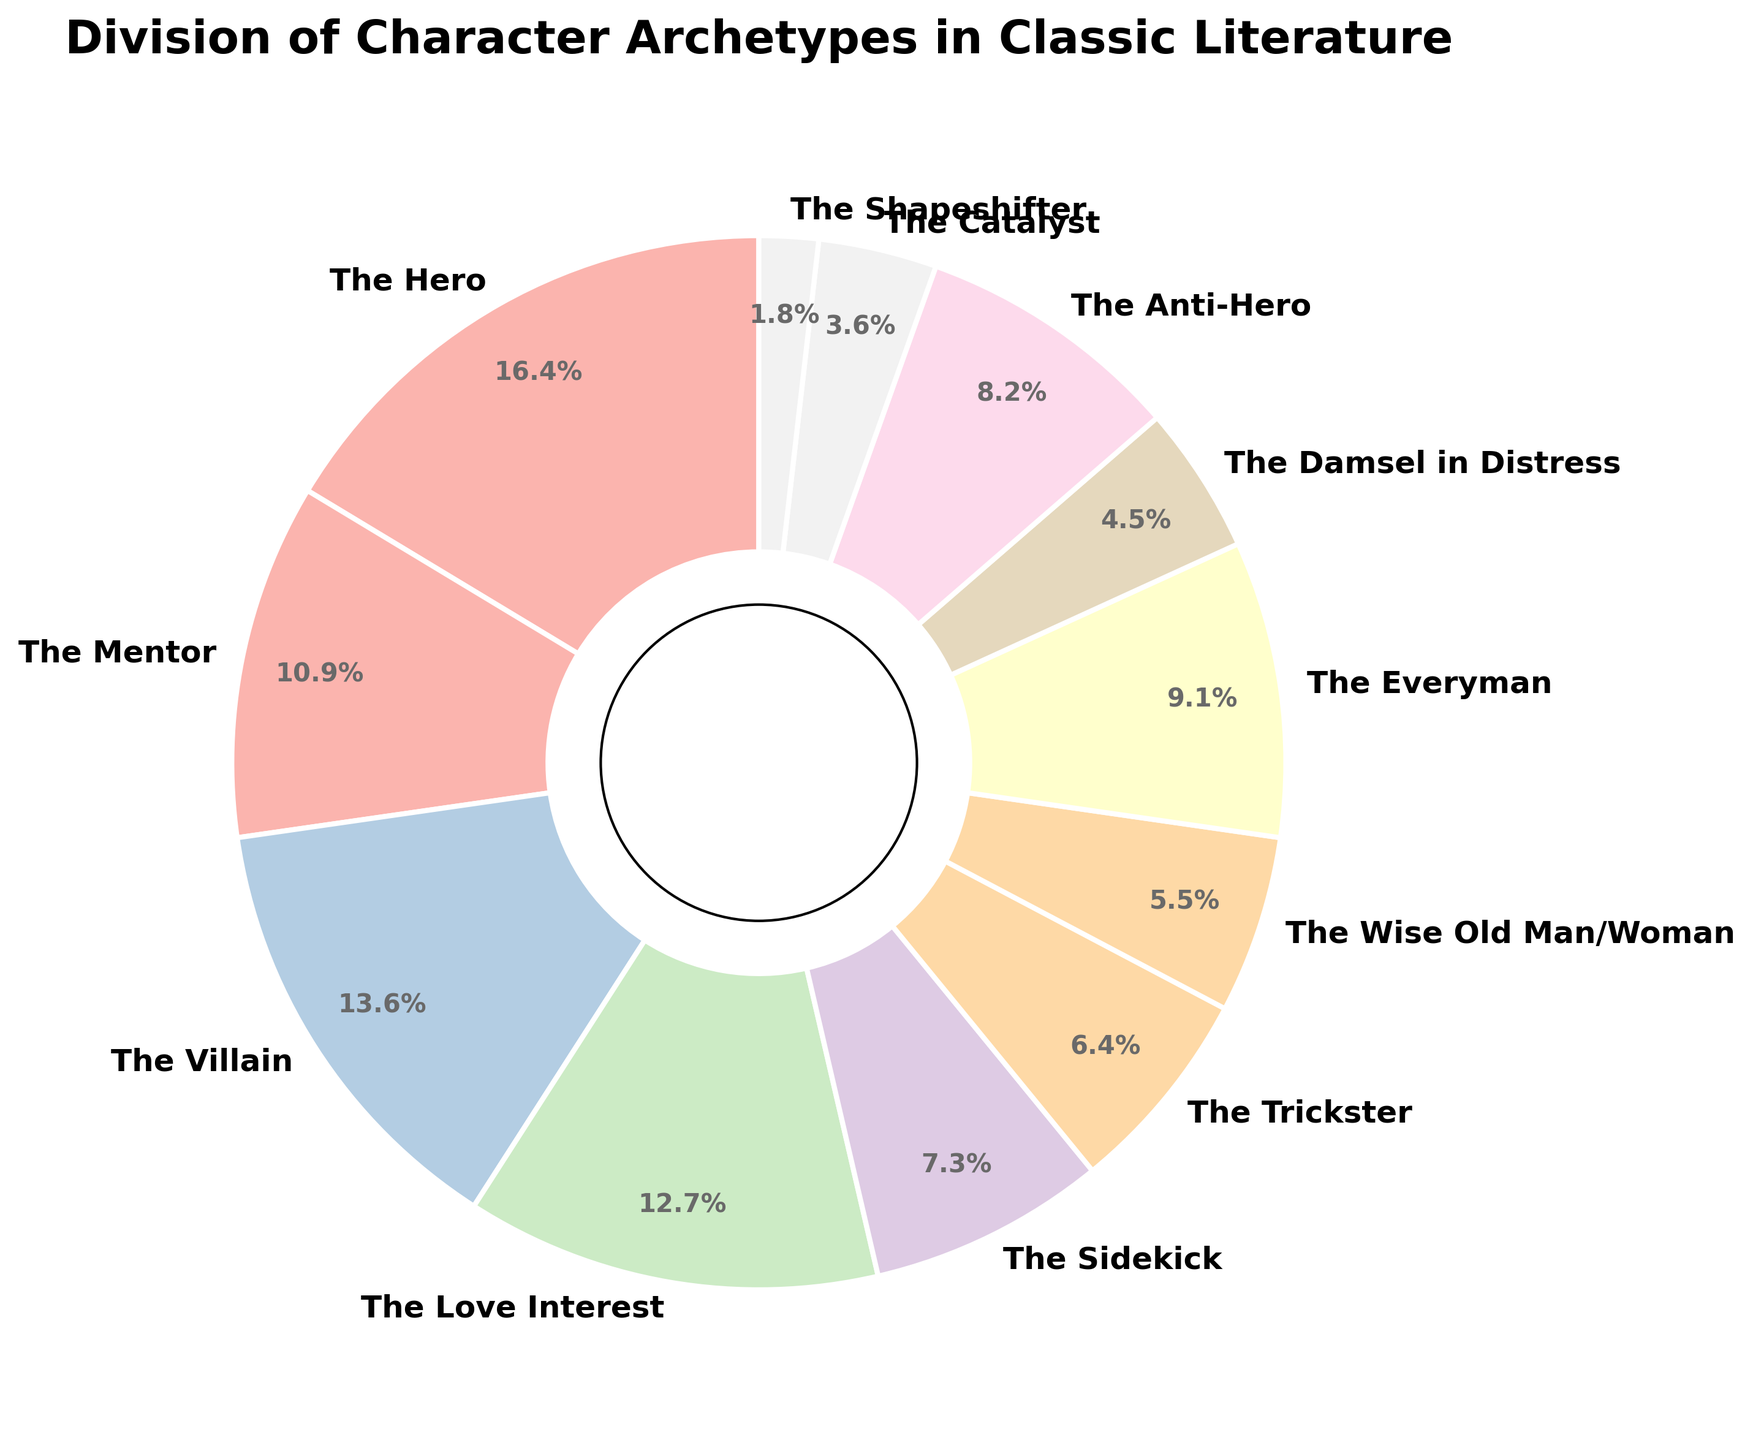Which character archetype has the highest percentage? By looking at the pie chart, we observe that "The Hero" has the largest section. Hence, "The Hero" has the highest percentage.
Answer: The Hero What is the combined percentage of "The Mentor" and "The Villain"? According to the pie chart, "The Mentor" has 12% and "The Villain" has 15%. Summing these values gives 12% + 15% = 27%.
Answer: 27% How many character archetypes have a percentage of less than 10%? By examining the chart, the following archetypes are less than 10%: "The Sidekick" (8%), "The Trickster" (7%), "The Wise Old Man/Woman" (6%), "The Everyman" (10%-less than, so not included), "The Damsel in Distress" (5%), "The Catalyst" (4%), "The Shapeshifter" (2%). Thus, there are 6 archetypes under 10%.
Answer: 6 Which has a larger percentage, "The Love Interest" or "The Anti-Hero"? From the pie chart, "The Love Interest" has 14%, whereas "The Anti-Hero" has 9%, making "The Love Interest"'s percentage greater than "The Anti-Hero"'s.
Answer: The Love Interest Are there more character archetypes with percentages above or below 10%? Counting from the pie chart: Above 10%: "The Hero" (18%), "The Mentor" (12%), "The Villain" (15%), "The Love Interest" (14%), totaling 4 archetypes. Below 10%: "The Sidekick" (8%), "The Trickster" (7%), "The Wise Old Man/Woman" (6%), "The Damsel in Distress" (5%), "The Anti-Hero" (9%), "The Catalyst" (4%), "The Shapeshifter" (2%), totaling 7 archetypes. Hence, more character archetypes fall below 10%.
Answer: Below What is the percentage difference between "The Hero" and "The Shapeshifter"? "The Hero" is 18% and "The Shapeshifter" is 2%. The difference is 18% - 2% = 16%.
Answer: 16% Which character archetypes together make up exactly 25%? Referring to the pie chart, "The Trickster" (7%) and "The Everyman" (10%) together are 7% + 10% = 17%, and adding "The Catalyst" (4%) totals 21%. This combination isn't exactly 25%. We need another set. Summing "The Love Interest" (14%) plus "The Anti-Hero" (9%) equals 14% + 9% = 23%, and it's not 25%. Instead, "The Villain" (15%) + "The Damsel in Distress" (5%) yields 20%, and needs more. After a thorough check, thus no pairs or trio sums to exactly 25% in the given pie chart.
Answer: No exact match 